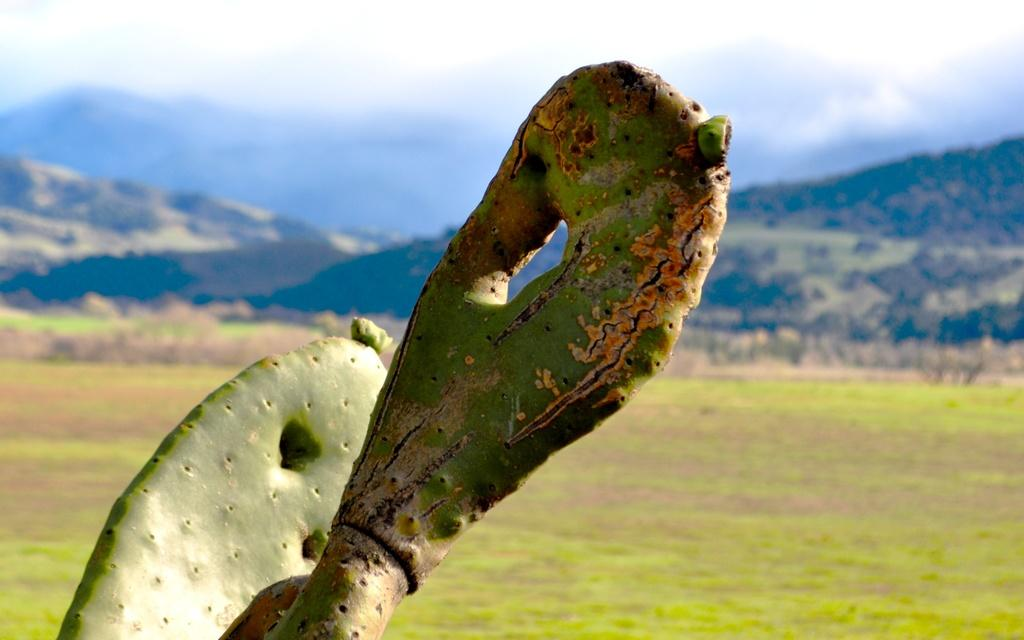What type of plant is in the image? There is a cactus plant in the image. What is on the ground in the image? There is grass visible on the ground. What can be seen in the distance in the image? There are mountains in the background of the image. What is the condition of the sky in the image? The sky is cloudy in the image. How many cats can be seen playing in the grass in the image? There are no cats present in the image; it features a cactus plant, grass, mountains, and a cloudy sky. Is there any indication of flight in the image? There is no indication of flight in the image; it does not depict any flying objects or activities. 